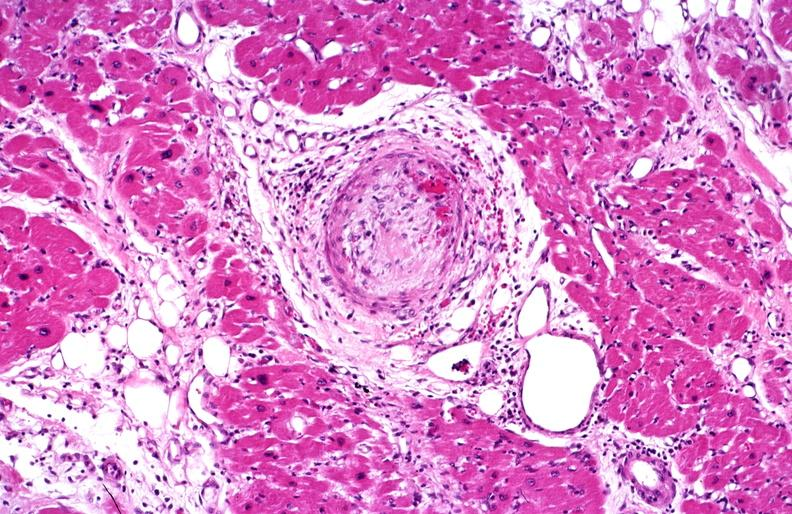does adenocarcinoma show heart, polyarteritis nodosa?
Answer the question using a single word or phrase. No 